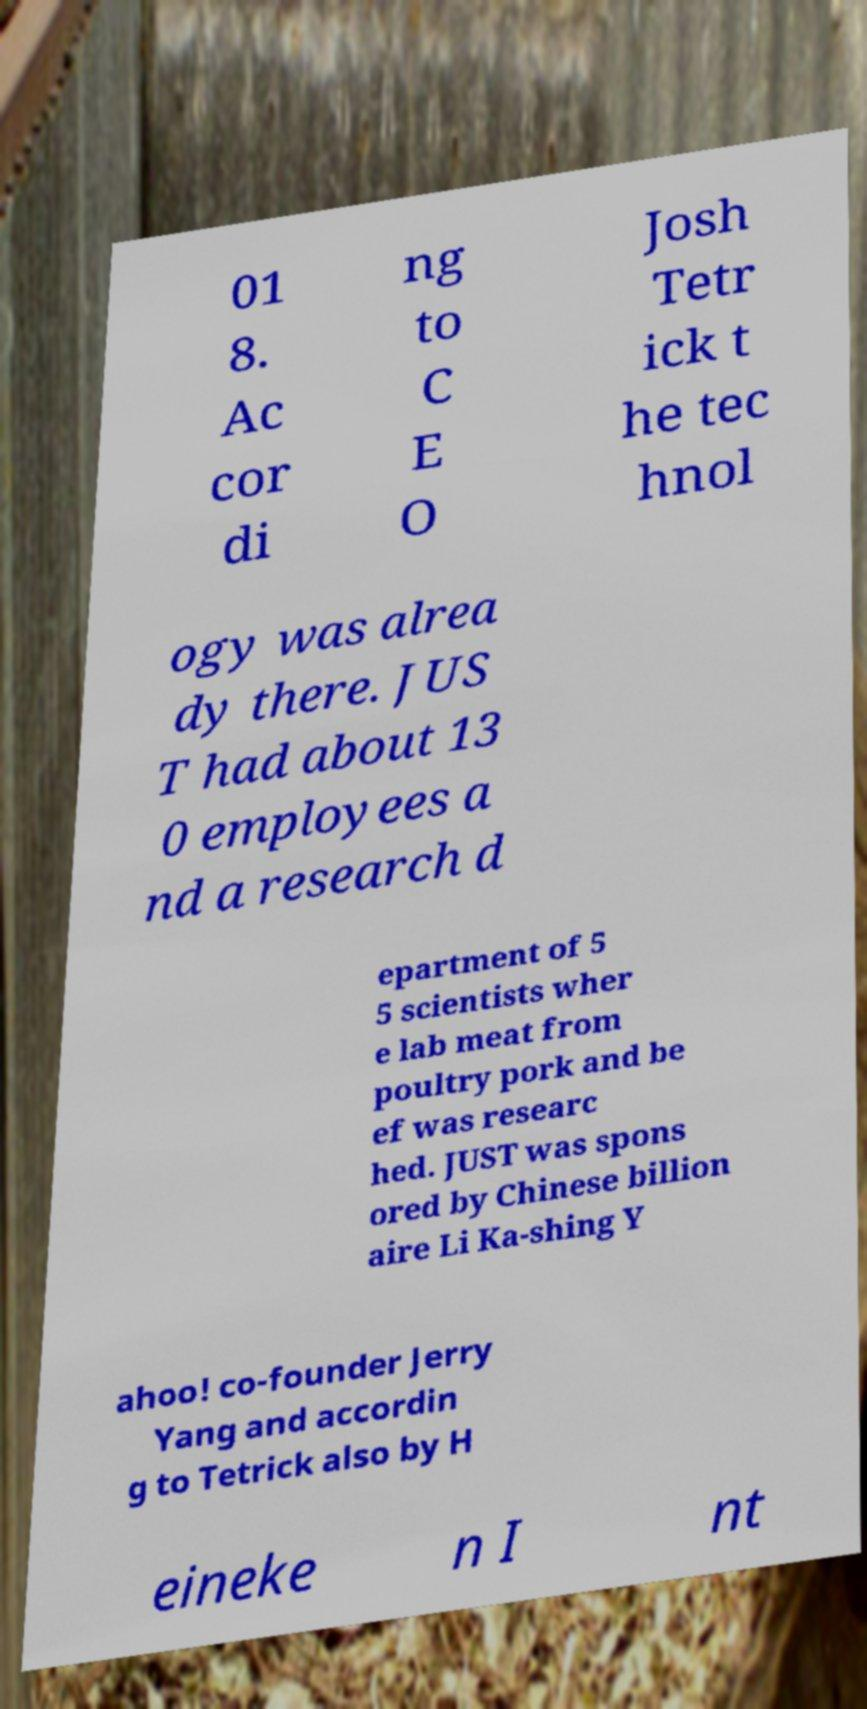Please identify and transcribe the text found in this image. 01 8. Ac cor di ng to C E O Josh Tetr ick t he tec hnol ogy was alrea dy there. JUS T had about 13 0 employees a nd a research d epartment of 5 5 scientists wher e lab meat from poultry pork and be ef was researc hed. JUST was spons ored by Chinese billion aire Li Ka-shing Y ahoo! co-founder Jerry Yang and accordin g to Tetrick also by H eineke n I nt 